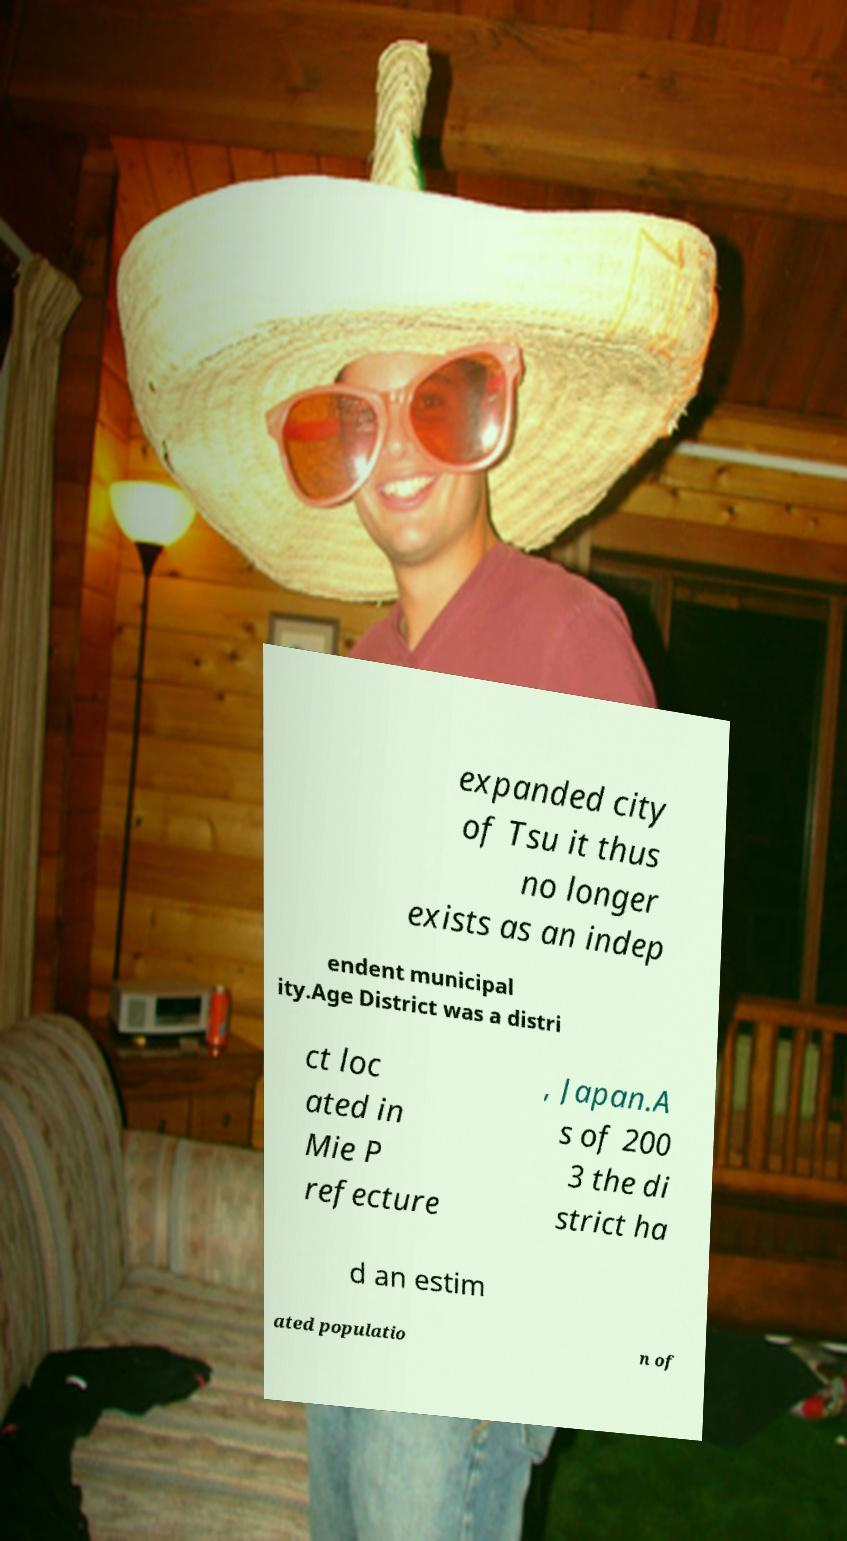What messages or text are displayed in this image? I need them in a readable, typed format. expanded city of Tsu it thus no longer exists as an indep endent municipal ity.Age District was a distri ct loc ated in Mie P refecture , Japan.A s of 200 3 the di strict ha d an estim ated populatio n of 